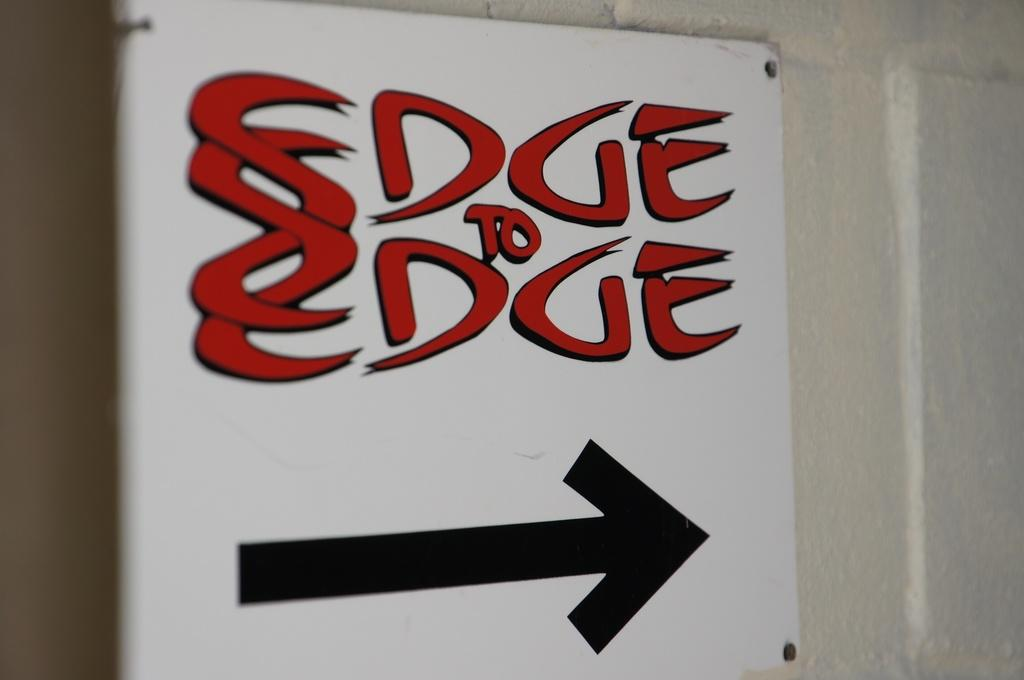<image>
Share a concise interpretation of the image provided. A sign attached to a wall. It says Edge to Edge and had a black arrow pointing right 